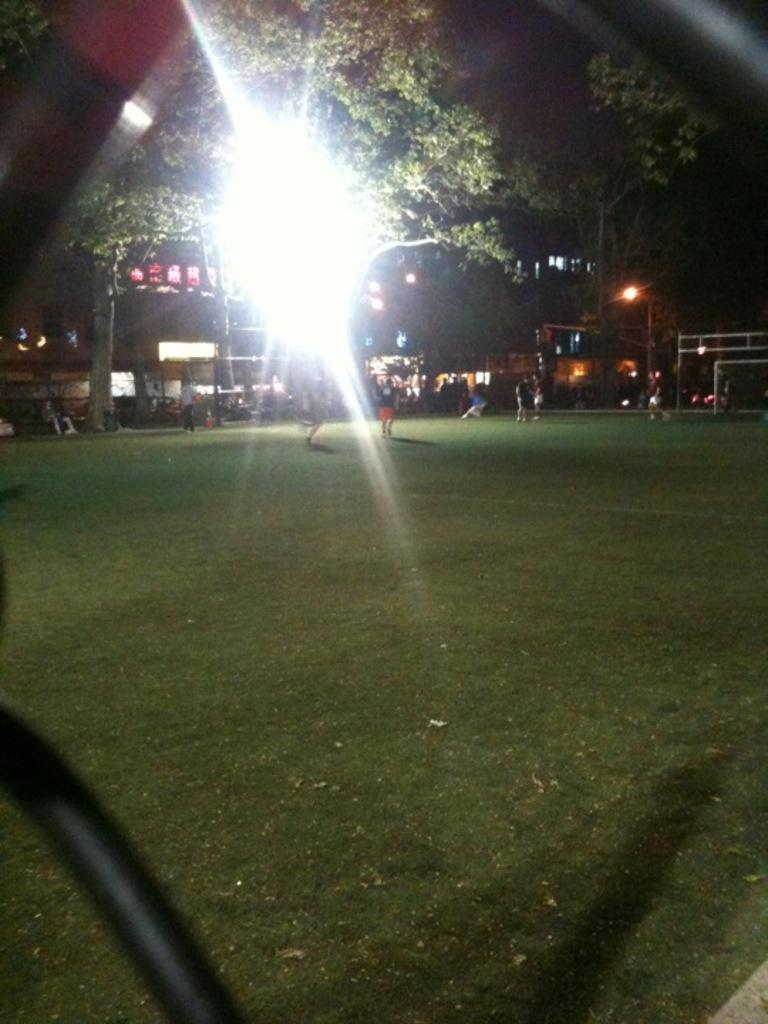How would you summarize this image in a sentence or two? In the image we can see there are people standing on the ground and the ground is covered with grass. There is lighting and behind there are trees and buildings. 